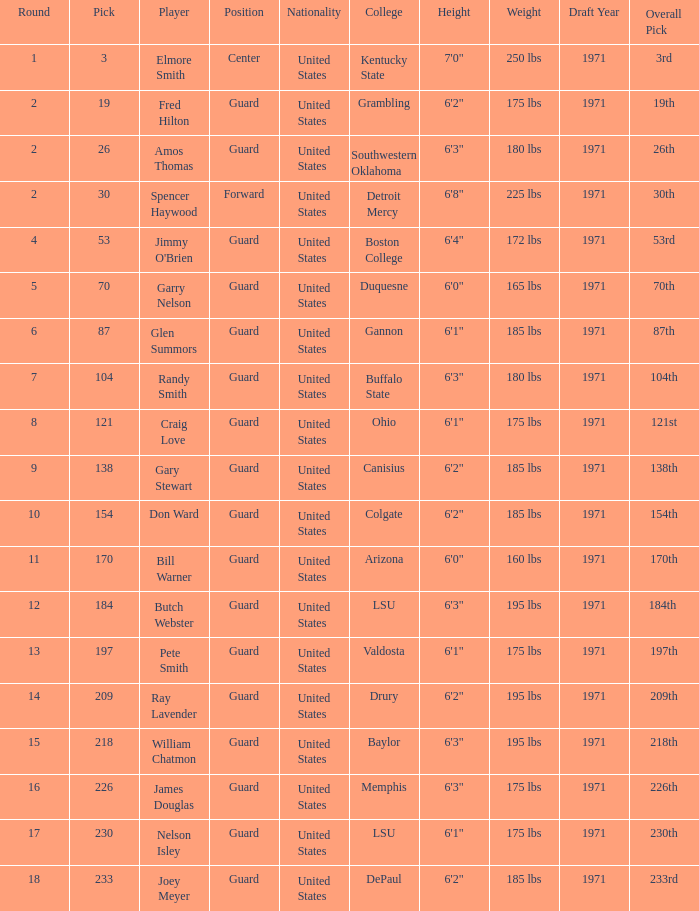WHAT ROUND HAS A GUARD POSITION AT OHIO COLLEGE? 8.0. 